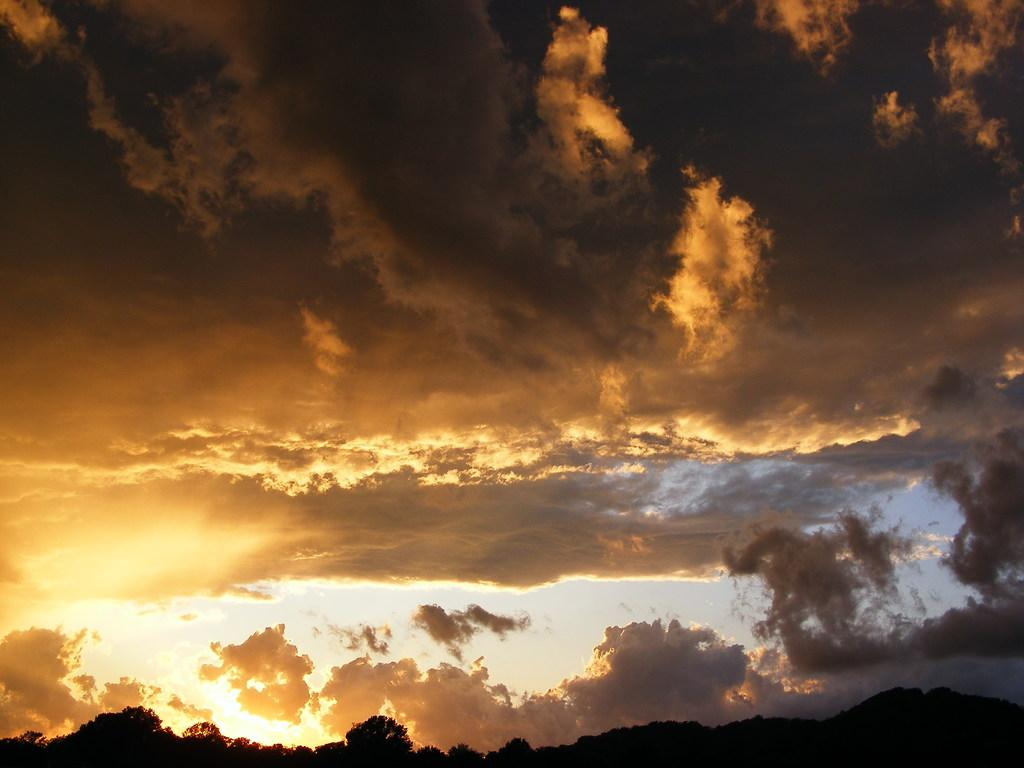What can be seen in the sky in the image? There are: There are clouds in the sky in the image. What type of vegetation is visible at the bottom of the image? There are trees visible at the bottom of the image. What type of fan is visible in the image? There is no fan present in the image. What arithmetic problem can be solved using the clouds in the image? There is no arithmetic problem associated with the clouds in the image, as they are a natural atmospheric phenomenon and not related to mathematics. 